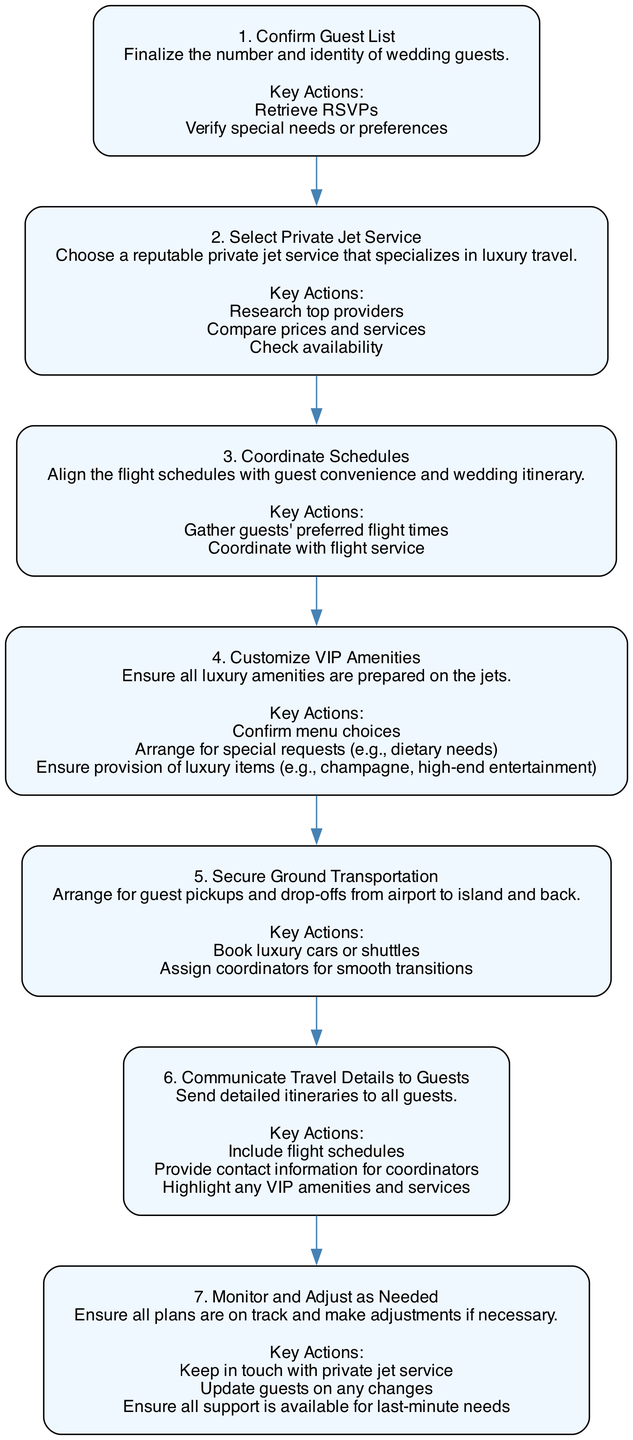What is the first step in the diagram? The first step is indicated at the top of the flow chart, which is to "Confirm Guest List". This is the first node and begins the booking and coordination process for the private jet transportation.
Answer: Confirm Guest List How many steps are in the diagram? By counting the number of nodes added in the flow chart, there are a total of seven steps represented in the diagram.
Answer: 7 What is the fourth step in the process? The fourth step listed in the flow chart is "Customize VIP Amenities". This step emphasizes ensuring all luxury amenities are prepared on the jets for the guests.
Answer: Customize VIP Amenities Which step comes immediately after "Select Private Jet Service"? Following the flow chart's sequence, the step that comes immediately after "Select Private Jet Service" is "Coordinate Schedules". This indicates a progression in the process.
Answer: Coordinate Schedules What key action is associated with the step "Secure Ground Transportation"? The key actions for this step include "Book luxury cars or shuttles". This indicates what needs to be arranged for the transportation of guests from the airport to the island.
Answer: Book luxury cars or shuttles How does the last step relate to the others? The last step, "Monitor and Adjust as Needed", relates to monitoring the entire process and ensuring that everything is running smoothly. This shows that the final step is crucial for overseeing all previous steps and making necessary adjustments.
Answer: Overseeing the process What is the main focus of step 3? The main focus of step 3, "Coordinate Schedules", is to align flight schedules with guest convenience and the overall wedding itinerary, indicating the importance of timing in the transportation process.
Answer: Aligning flight schedules What must be confirmed in step 4? In step 4, "Customize VIP Amenities", it is essential to confirm menu choices as part of ensuring that all luxury amenities are adequately prepared for the guests on the private jets.
Answer: Confirm menu choices 